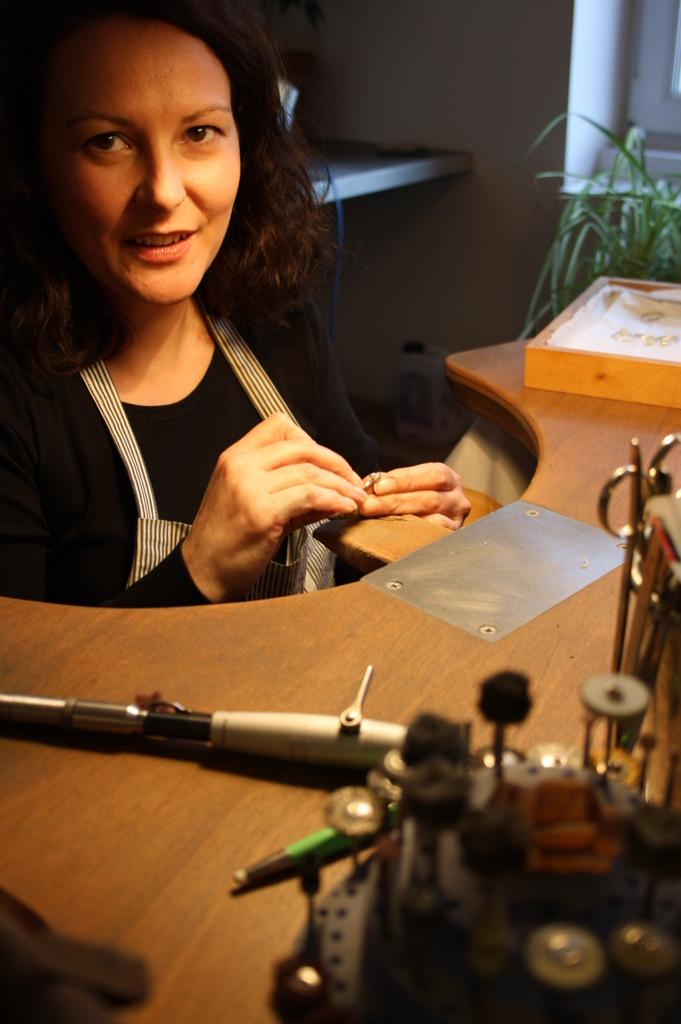What type of objects are on the wooden surface in the image? There are metal objects on a wooden surface in the image. Can you describe the person in the image? There is a person in the image, but no specific details about their appearance or actions are provided. What can be seen on the right side of the image? There is a plant on the right side of the image. What rule does the man in the image enforce? There is no man present in the image, and therefore no rule enforcement can be observed. How does the plant stop the metal objects from moving? The plant does not stop the metal objects from moving; it is a separate element in the image. 